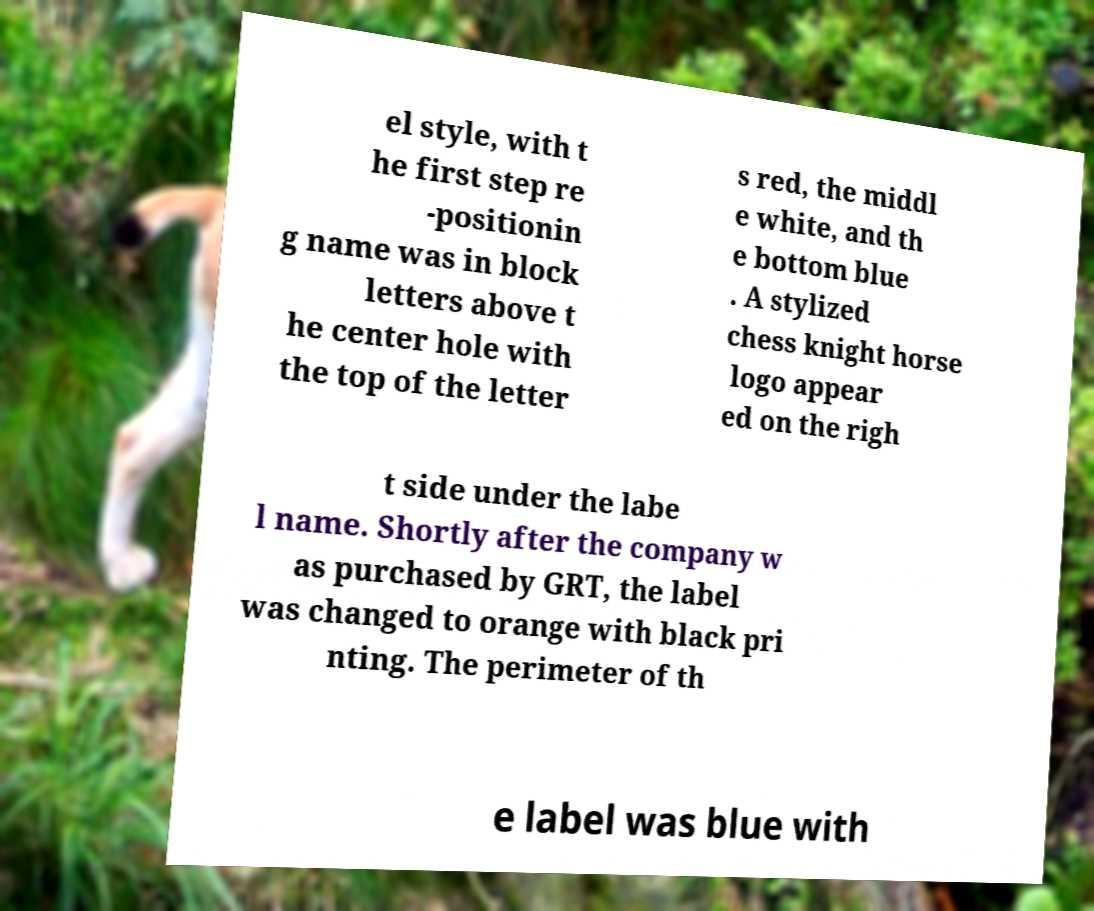Could you assist in decoding the text presented in this image and type it out clearly? el style, with t he first step re -positionin g name was in block letters above t he center hole with the top of the letter s red, the middl e white, and th e bottom blue . A stylized chess knight horse logo appear ed on the righ t side under the labe l name. Shortly after the company w as purchased by GRT, the label was changed to orange with black pri nting. The perimeter of th e label was blue with 